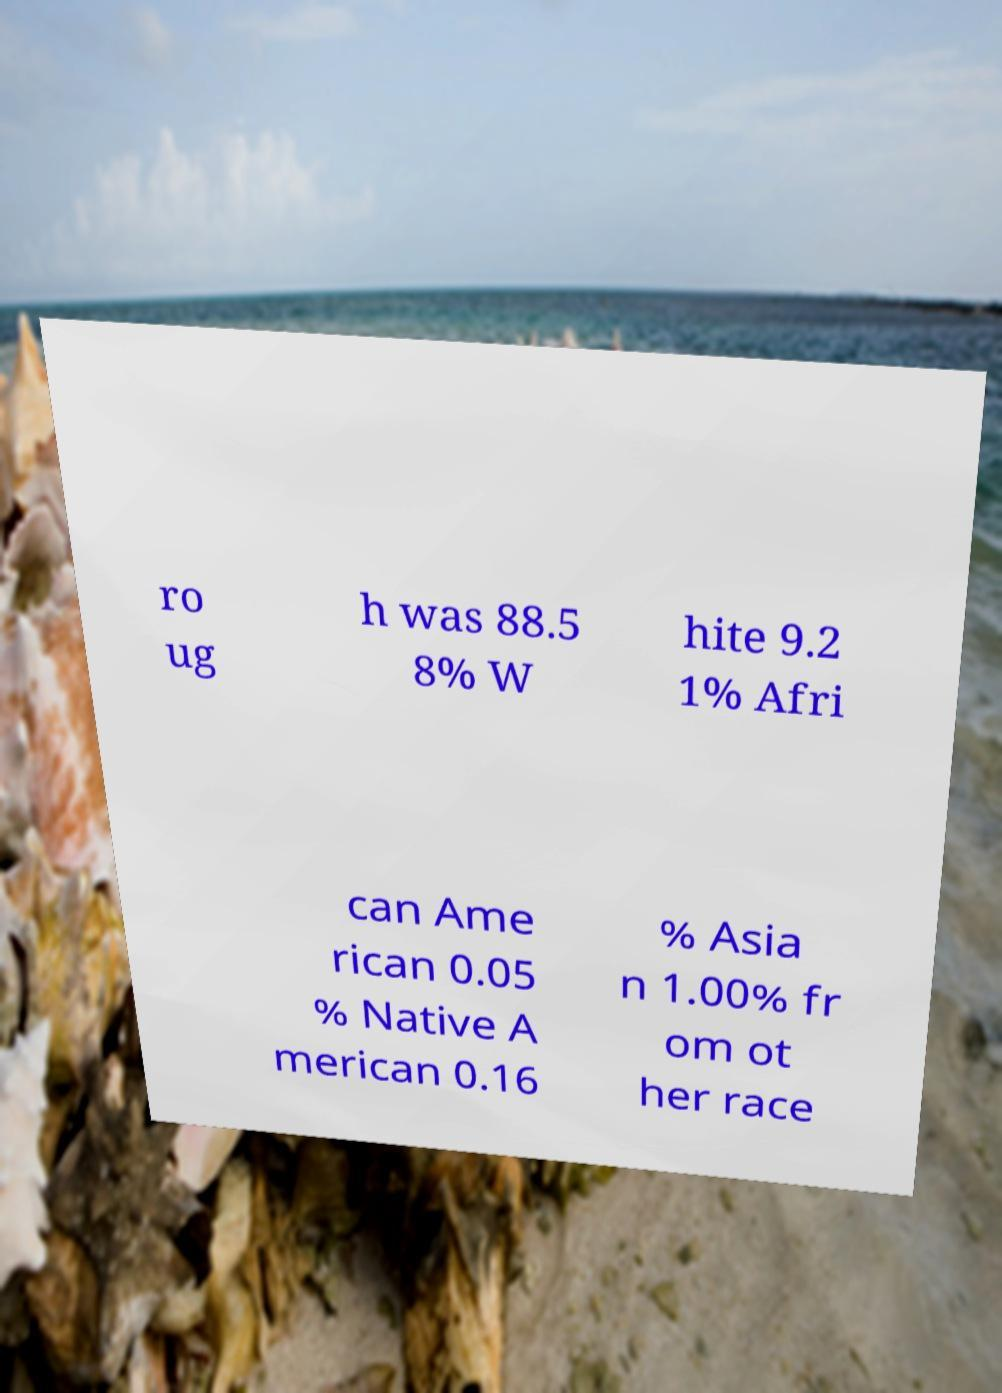I need the written content from this picture converted into text. Can you do that? ro ug h was 88.5 8% W hite 9.2 1% Afri can Ame rican 0.05 % Native A merican 0.16 % Asia n 1.00% fr om ot her race 